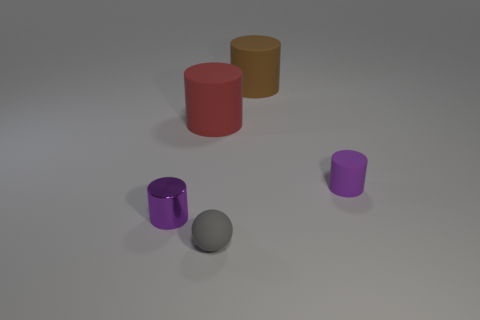Subtract all yellow balls. Subtract all green cylinders. How many balls are left? 1 Add 3 brown matte cylinders. How many objects exist? 8 Subtract all balls. How many objects are left? 4 Subtract 0 yellow cylinders. How many objects are left? 5 Subtract all big brown matte cubes. Subtract all purple things. How many objects are left? 3 Add 4 rubber cylinders. How many rubber cylinders are left? 7 Add 2 cylinders. How many cylinders exist? 6 